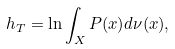Convert formula to latex. <formula><loc_0><loc_0><loc_500><loc_500>h _ { T } = \ln \int _ { X } P ( x ) d \nu ( x ) ,</formula> 